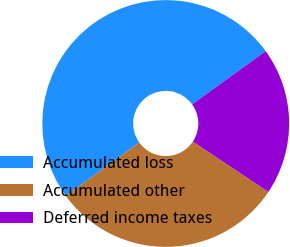<chart> <loc_0><loc_0><loc_500><loc_500><pie_chart><fcel>Accumulated loss<fcel>Accumulated other<fcel>Deferred income taxes<nl><fcel>50.0%<fcel>30.67%<fcel>19.33%<nl></chart> 